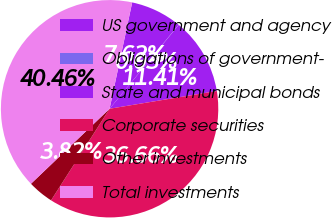<chart> <loc_0><loc_0><loc_500><loc_500><pie_chart><fcel>US government and agency<fcel>Obligations of government-<fcel>State and municipal bonds<fcel>Corporate securities<fcel>Other investments<fcel>Total investments<nl><fcel>7.62%<fcel>0.03%<fcel>11.41%<fcel>36.66%<fcel>3.82%<fcel>40.46%<nl></chart> 